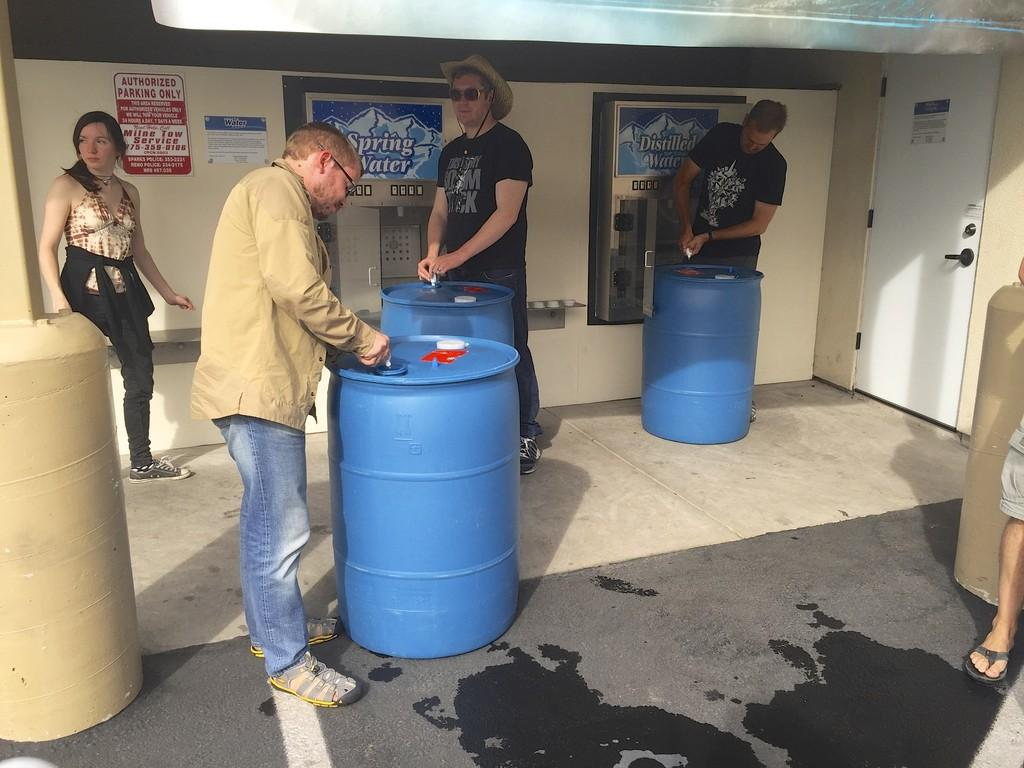<image>
Describe the image concisely. A few people are gathered around barrels in front of a spring water station. 